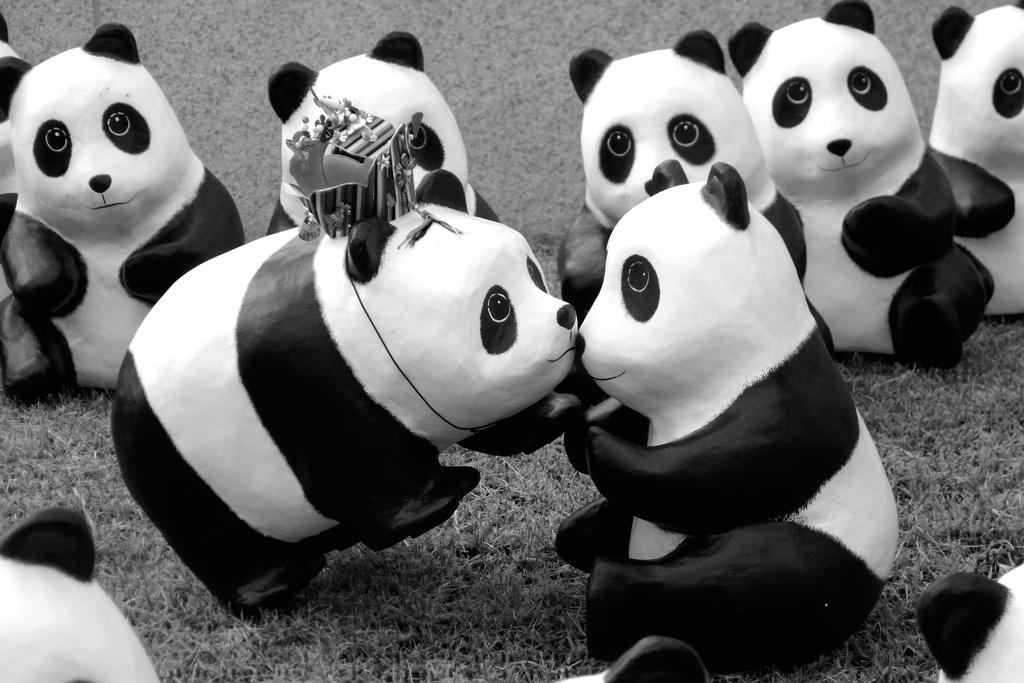What is the color scheme of the image? The image is black and white. What type of objects can be seen in the image? There are many toy pandas in the image. Can you describe the texture of the worm in the image? There is no worm present in the image; it only features toy pandas. 